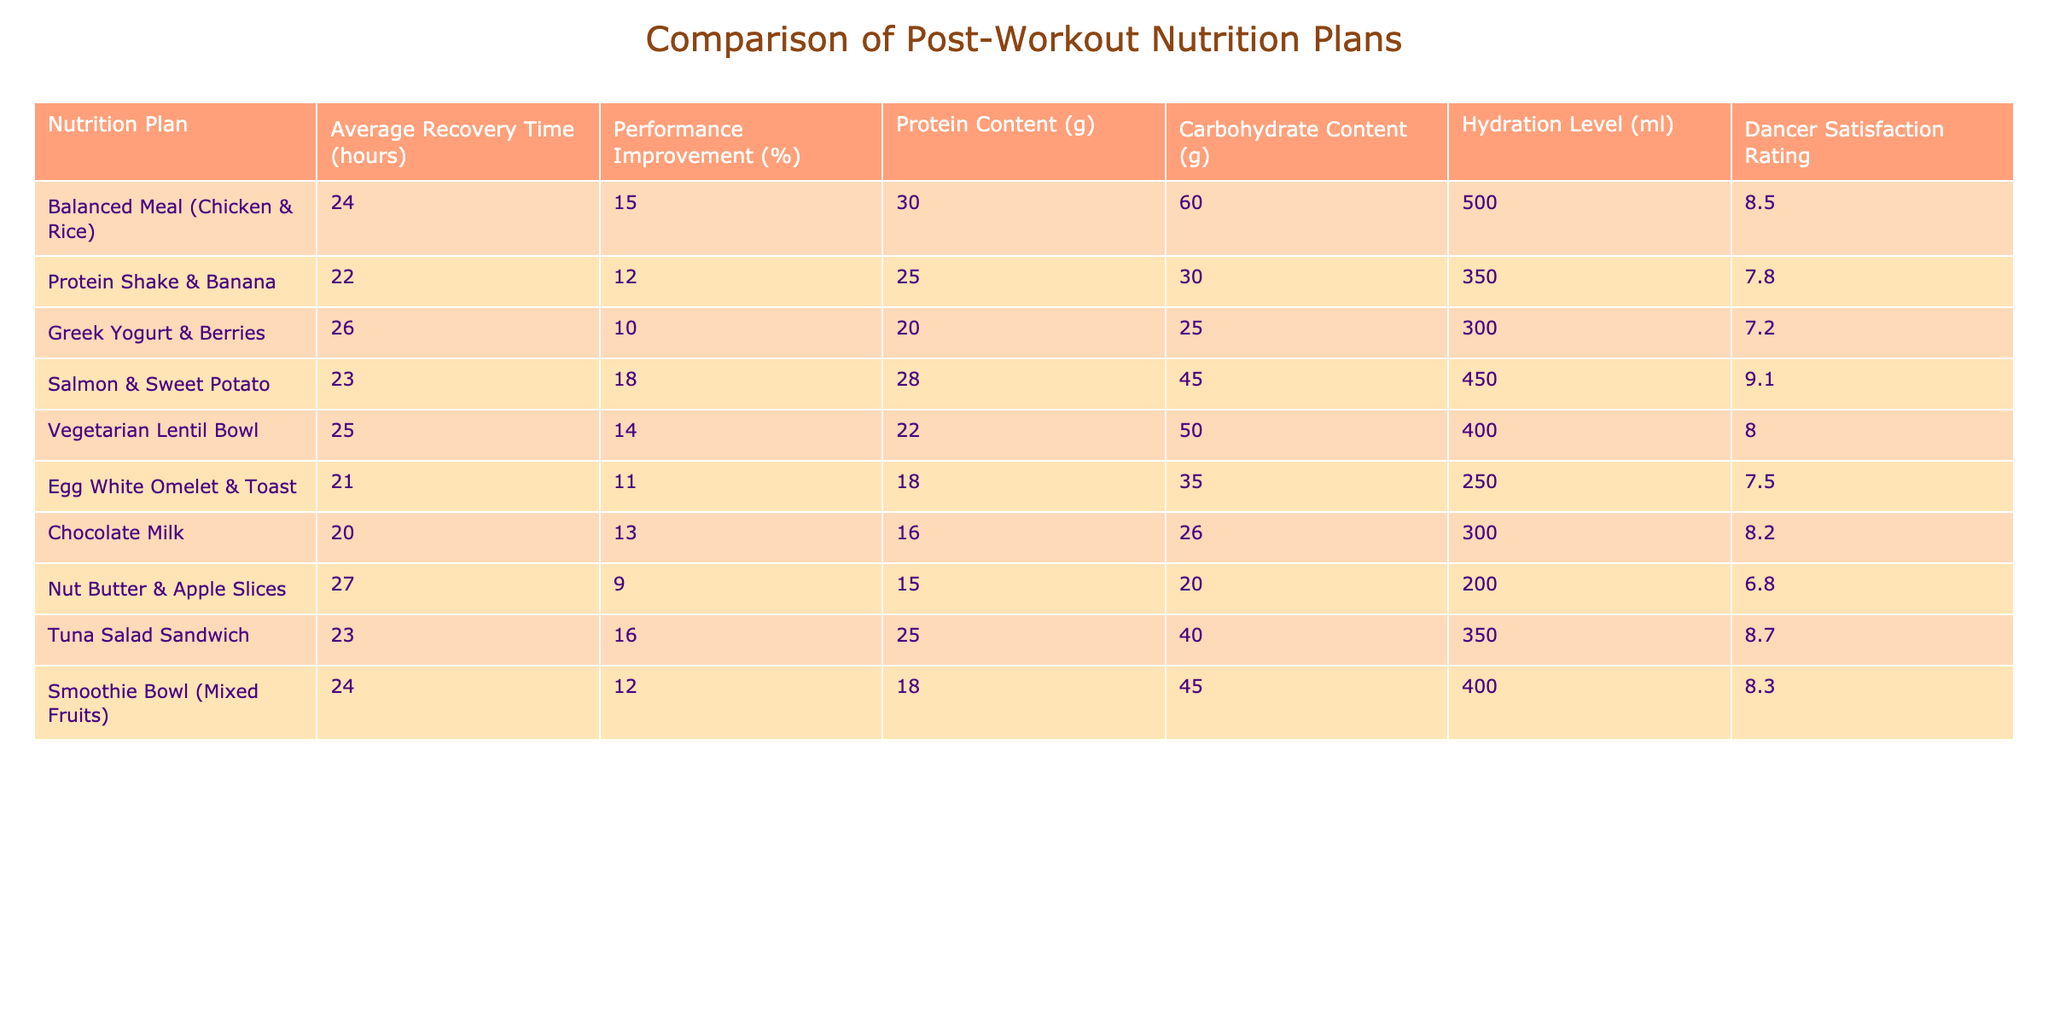What is the average recovery time for the Protein Shake & Banana nutrition plan? The table indicates that the average recovery time for the Protein Shake & Banana is listed as 22 hours.
Answer: 22 hours Which nutrition plan had the highest performance improvement percentage? By comparing the performance improvement percentages listed, the Salmon & Sweet Potato nutrition plan has the highest percentage at 18%.
Answer: 18% Is the Tuna Salad Sandwich effective for recovery based on its average recovery time? The average recovery time for the Tuna Salad Sandwich is 23 hours, which is relatively moderate. Since it also has a performance improvement of 16%, it can be considered effective for recovery, though not the best option.
Answer: Yes What is the total protein content of the Balanced Meal (Chicken & Rice) and the Egg White Omelet & Toast combined? The protein content for the Balanced Meal is 30 grams and for the Egg White Omelet is 18 grams. Adding these together gives 30 + 18 = 48 grams of protein.
Answer: 48 grams How many nutrition plans have a dancer satisfaction rating of 8 or higher? The table shows that four nutrition plans (Balanced Meal, Salmon & Sweet Potato, Tuna Salad Sandwich, and Smoothie Bowl) have satisfaction ratings of 8 or higher.
Answer: 4 Which plan has the highest carbohydrate content, and what is that value? Upon reviewing the carbohydrate content, the Vegetarian Lentil Bowl has the highest with 50 grams.
Answer: 50 grams If we look at the hydration level, which nutrition plan has the lowest hydration level, and what is the value? The Nut Butter & Apple Slices has a hydration level of 200 ml, which is the lowest when compared to other plans.
Answer: 200 ml What is the difference in average recovery time between the Chocolate Milk and Greek Yogurt & Berries plans? The average recovery time for Chocolate Milk is 20 hours, and for Greek Yogurt & Berries, it is 26 hours. The difference is calculated as 26 - 20 = 6 hours.
Answer: 6 hours Are there more nutrition plans with protein content greater than 25 grams than those with protein content less than or equal to 25 grams? By counting the plans, we find that there are five plans with protein content greater than 25 grams (Balanced Meal, Salmon & Sweet Potato, Tuna Salad Sandwich) and four with 25 grams or less (Protein Shake & Banana, Greek Yogurt & Berries, Egg White Omelet, Nut Butter & Apple Slices). Therefore, there are more plans with higher protein content.
Answer: Yes 